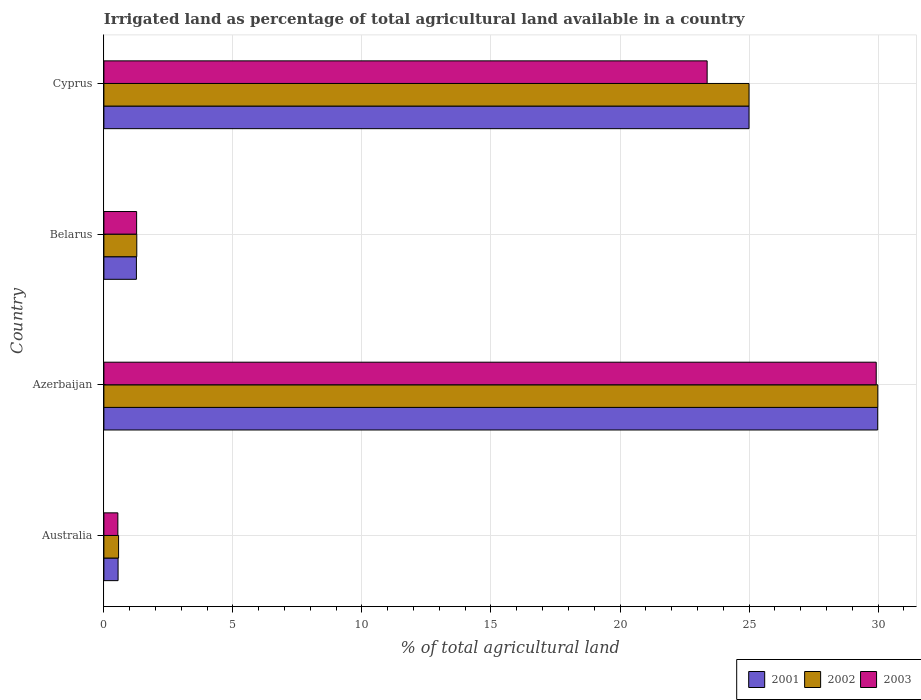How many groups of bars are there?
Ensure brevity in your answer.  4. What is the label of the 2nd group of bars from the top?
Your response must be concise. Belarus. In how many cases, is the number of bars for a given country not equal to the number of legend labels?
Your response must be concise. 0. What is the percentage of irrigated land in 2003 in Australia?
Your answer should be very brief. 0.54. Across all countries, what is the maximum percentage of irrigated land in 2002?
Offer a terse response. 29.99. Across all countries, what is the minimum percentage of irrigated land in 2001?
Ensure brevity in your answer.  0.55. In which country was the percentage of irrigated land in 2002 maximum?
Ensure brevity in your answer.  Azerbaijan. What is the total percentage of irrigated land in 2002 in the graph?
Your answer should be compact. 56.83. What is the difference between the percentage of irrigated land in 2002 in Azerbaijan and that in Belarus?
Your answer should be very brief. 28.72. What is the difference between the percentage of irrigated land in 2003 in Cyprus and the percentage of irrigated land in 2002 in Australia?
Keep it short and to the point. 22.81. What is the average percentage of irrigated land in 2002 per country?
Your answer should be compact. 14.21. What is the difference between the percentage of irrigated land in 2002 and percentage of irrigated land in 2001 in Australia?
Make the answer very short. 0.02. What is the ratio of the percentage of irrigated land in 2002 in Australia to that in Belarus?
Your response must be concise. 0.45. Is the percentage of irrigated land in 2002 in Azerbaijan less than that in Cyprus?
Make the answer very short. No. What is the difference between the highest and the second highest percentage of irrigated land in 2003?
Your answer should be very brief. 6.55. What is the difference between the highest and the lowest percentage of irrigated land in 2003?
Give a very brief answer. 29.39. In how many countries, is the percentage of irrigated land in 2003 greater than the average percentage of irrigated land in 2003 taken over all countries?
Your answer should be very brief. 2. Is it the case that in every country, the sum of the percentage of irrigated land in 2003 and percentage of irrigated land in 2002 is greater than the percentage of irrigated land in 2001?
Give a very brief answer. Yes. What is the difference between two consecutive major ticks on the X-axis?
Offer a terse response. 5. How are the legend labels stacked?
Give a very brief answer. Horizontal. What is the title of the graph?
Provide a short and direct response. Irrigated land as percentage of total agricultural land available in a country. What is the label or title of the X-axis?
Your answer should be very brief. % of total agricultural land. What is the % of total agricultural land in 2001 in Australia?
Provide a succinct answer. 0.55. What is the % of total agricultural land of 2002 in Australia?
Give a very brief answer. 0.57. What is the % of total agricultural land in 2003 in Australia?
Keep it short and to the point. 0.54. What is the % of total agricultural land of 2001 in Azerbaijan?
Provide a short and direct response. 29.99. What is the % of total agricultural land in 2002 in Azerbaijan?
Ensure brevity in your answer.  29.99. What is the % of total agricultural land in 2003 in Azerbaijan?
Ensure brevity in your answer.  29.93. What is the % of total agricultural land in 2001 in Belarus?
Offer a very short reply. 1.26. What is the % of total agricultural land in 2002 in Belarus?
Your answer should be compact. 1.27. What is the % of total agricultural land in 2003 in Belarus?
Your response must be concise. 1.27. What is the % of total agricultural land of 2003 in Cyprus?
Give a very brief answer. 23.38. Across all countries, what is the maximum % of total agricultural land in 2001?
Offer a very short reply. 29.99. Across all countries, what is the maximum % of total agricultural land of 2002?
Provide a succinct answer. 29.99. Across all countries, what is the maximum % of total agricultural land in 2003?
Your response must be concise. 29.93. Across all countries, what is the minimum % of total agricultural land in 2001?
Your answer should be very brief. 0.55. Across all countries, what is the minimum % of total agricultural land in 2002?
Keep it short and to the point. 0.57. Across all countries, what is the minimum % of total agricultural land of 2003?
Make the answer very short. 0.54. What is the total % of total agricultural land of 2001 in the graph?
Make the answer very short. 56.8. What is the total % of total agricultural land in 2002 in the graph?
Give a very brief answer. 56.83. What is the total % of total agricultural land in 2003 in the graph?
Keep it short and to the point. 55.12. What is the difference between the % of total agricultural land in 2001 in Australia and that in Azerbaijan?
Offer a very short reply. -29.44. What is the difference between the % of total agricultural land of 2002 in Australia and that in Azerbaijan?
Your answer should be compact. -29.42. What is the difference between the % of total agricultural land of 2003 in Australia and that in Azerbaijan?
Give a very brief answer. -29.39. What is the difference between the % of total agricultural land of 2001 in Australia and that in Belarus?
Offer a very short reply. -0.71. What is the difference between the % of total agricultural land in 2002 in Australia and that in Belarus?
Give a very brief answer. -0.7. What is the difference between the % of total agricultural land of 2003 in Australia and that in Belarus?
Provide a short and direct response. -0.73. What is the difference between the % of total agricultural land of 2001 in Australia and that in Cyprus?
Offer a terse response. -24.45. What is the difference between the % of total agricultural land of 2002 in Australia and that in Cyprus?
Your response must be concise. -24.43. What is the difference between the % of total agricultural land of 2003 in Australia and that in Cyprus?
Ensure brevity in your answer.  -22.84. What is the difference between the % of total agricultural land of 2001 in Azerbaijan and that in Belarus?
Provide a succinct answer. 28.73. What is the difference between the % of total agricultural land of 2002 in Azerbaijan and that in Belarus?
Give a very brief answer. 28.72. What is the difference between the % of total agricultural land in 2003 in Azerbaijan and that in Belarus?
Provide a short and direct response. 28.66. What is the difference between the % of total agricultural land of 2001 in Azerbaijan and that in Cyprus?
Provide a succinct answer. 4.99. What is the difference between the % of total agricultural land of 2002 in Azerbaijan and that in Cyprus?
Provide a succinct answer. 4.99. What is the difference between the % of total agricultural land of 2003 in Azerbaijan and that in Cyprus?
Make the answer very short. 6.55. What is the difference between the % of total agricultural land of 2001 in Belarus and that in Cyprus?
Make the answer very short. -23.74. What is the difference between the % of total agricultural land in 2002 in Belarus and that in Cyprus?
Your answer should be very brief. -23.73. What is the difference between the % of total agricultural land in 2003 in Belarus and that in Cyprus?
Your response must be concise. -22.11. What is the difference between the % of total agricultural land of 2001 in Australia and the % of total agricultural land of 2002 in Azerbaijan?
Make the answer very short. -29.44. What is the difference between the % of total agricultural land of 2001 in Australia and the % of total agricultural land of 2003 in Azerbaijan?
Your answer should be compact. -29.38. What is the difference between the % of total agricultural land in 2002 in Australia and the % of total agricultural land in 2003 in Azerbaijan?
Keep it short and to the point. -29.36. What is the difference between the % of total agricultural land of 2001 in Australia and the % of total agricultural land of 2002 in Belarus?
Offer a terse response. -0.72. What is the difference between the % of total agricultural land in 2001 in Australia and the % of total agricultural land in 2003 in Belarus?
Your answer should be compact. -0.72. What is the difference between the % of total agricultural land of 2002 in Australia and the % of total agricultural land of 2003 in Belarus?
Provide a succinct answer. -0.7. What is the difference between the % of total agricultural land of 2001 in Australia and the % of total agricultural land of 2002 in Cyprus?
Your response must be concise. -24.45. What is the difference between the % of total agricultural land in 2001 in Australia and the % of total agricultural land in 2003 in Cyprus?
Your answer should be compact. -22.83. What is the difference between the % of total agricultural land in 2002 in Australia and the % of total agricultural land in 2003 in Cyprus?
Your response must be concise. -22.81. What is the difference between the % of total agricultural land in 2001 in Azerbaijan and the % of total agricultural land in 2002 in Belarus?
Provide a succinct answer. 28.71. What is the difference between the % of total agricultural land of 2001 in Azerbaijan and the % of total agricultural land of 2003 in Belarus?
Your answer should be very brief. 28.72. What is the difference between the % of total agricultural land of 2002 in Azerbaijan and the % of total agricultural land of 2003 in Belarus?
Your answer should be very brief. 28.72. What is the difference between the % of total agricultural land in 2001 in Azerbaijan and the % of total agricultural land in 2002 in Cyprus?
Your answer should be compact. 4.99. What is the difference between the % of total agricultural land of 2001 in Azerbaijan and the % of total agricultural land of 2003 in Cyprus?
Provide a short and direct response. 6.61. What is the difference between the % of total agricultural land in 2002 in Azerbaijan and the % of total agricultural land in 2003 in Cyprus?
Ensure brevity in your answer.  6.61. What is the difference between the % of total agricultural land of 2001 in Belarus and the % of total agricultural land of 2002 in Cyprus?
Your answer should be very brief. -23.74. What is the difference between the % of total agricultural land of 2001 in Belarus and the % of total agricultural land of 2003 in Cyprus?
Ensure brevity in your answer.  -22.12. What is the difference between the % of total agricultural land of 2002 in Belarus and the % of total agricultural land of 2003 in Cyprus?
Your response must be concise. -22.1. What is the average % of total agricultural land of 2001 per country?
Your answer should be compact. 14.2. What is the average % of total agricultural land of 2002 per country?
Make the answer very short. 14.21. What is the average % of total agricultural land of 2003 per country?
Your answer should be very brief. 13.78. What is the difference between the % of total agricultural land in 2001 and % of total agricultural land in 2002 in Australia?
Provide a succinct answer. -0.02. What is the difference between the % of total agricultural land in 2001 and % of total agricultural land in 2003 in Australia?
Ensure brevity in your answer.  0.01. What is the difference between the % of total agricultural land of 2002 and % of total agricultural land of 2003 in Australia?
Ensure brevity in your answer.  0.03. What is the difference between the % of total agricultural land of 2001 and % of total agricultural land of 2002 in Azerbaijan?
Give a very brief answer. -0. What is the difference between the % of total agricultural land of 2001 and % of total agricultural land of 2003 in Azerbaijan?
Make the answer very short. 0.06. What is the difference between the % of total agricultural land in 2002 and % of total agricultural land in 2003 in Azerbaijan?
Offer a very short reply. 0.06. What is the difference between the % of total agricultural land in 2001 and % of total agricultural land in 2002 in Belarus?
Provide a short and direct response. -0.01. What is the difference between the % of total agricultural land of 2001 and % of total agricultural land of 2003 in Belarus?
Keep it short and to the point. -0.01. What is the difference between the % of total agricultural land of 2002 and % of total agricultural land of 2003 in Belarus?
Your response must be concise. 0.01. What is the difference between the % of total agricultural land in 2001 and % of total agricultural land in 2003 in Cyprus?
Make the answer very short. 1.62. What is the difference between the % of total agricultural land of 2002 and % of total agricultural land of 2003 in Cyprus?
Provide a succinct answer. 1.62. What is the ratio of the % of total agricultural land in 2001 in Australia to that in Azerbaijan?
Your answer should be compact. 0.02. What is the ratio of the % of total agricultural land in 2002 in Australia to that in Azerbaijan?
Your response must be concise. 0.02. What is the ratio of the % of total agricultural land of 2003 in Australia to that in Azerbaijan?
Provide a succinct answer. 0.02. What is the ratio of the % of total agricultural land in 2001 in Australia to that in Belarus?
Provide a succinct answer. 0.44. What is the ratio of the % of total agricultural land in 2002 in Australia to that in Belarus?
Your answer should be compact. 0.45. What is the ratio of the % of total agricultural land of 2003 in Australia to that in Belarus?
Your answer should be compact. 0.43. What is the ratio of the % of total agricultural land in 2001 in Australia to that in Cyprus?
Ensure brevity in your answer.  0.02. What is the ratio of the % of total agricultural land of 2002 in Australia to that in Cyprus?
Keep it short and to the point. 0.02. What is the ratio of the % of total agricultural land of 2003 in Australia to that in Cyprus?
Provide a succinct answer. 0.02. What is the ratio of the % of total agricultural land of 2001 in Azerbaijan to that in Belarus?
Your answer should be very brief. 23.8. What is the ratio of the % of total agricultural land of 2002 in Azerbaijan to that in Belarus?
Offer a very short reply. 23.54. What is the ratio of the % of total agricultural land in 2003 in Azerbaijan to that in Belarus?
Keep it short and to the point. 23.59. What is the ratio of the % of total agricultural land of 2001 in Azerbaijan to that in Cyprus?
Give a very brief answer. 1.2. What is the ratio of the % of total agricultural land of 2002 in Azerbaijan to that in Cyprus?
Your answer should be compact. 1.2. What is the ratio of the % of total agricultural land in 2003 in Azerbaijan to that in Cyprus?
Your answer should be compact. 1.28. What is the ratio of the % of total agricultural land in 2001 in Belarus to that in Cyprus?
Your answer should be compact. 0.05. What is the ratio of the % of total agricultural land in 2002 in Belarus to that in Cyprus?
Provide a succinct answer. 0.05. What is the ratio of the % of total agricultural land of 2003 in Belarus to that in Cyprus?
Your answer should be very brief. 0.05. What is the difference between the highest and the second highest % of total agricultural land in 2001?
Your answer should be compact. 4.99. What is the difference between the highest and the second highest % of total agricultural land of 2002?
Give a very brief answer. 4.99. What is the difference between the highest and the second highest % of total agricultural land in 2003?
Make the answer very short. 6.55. What is the difference between the highest and the lowest % of total agricultural land in 2001?
Your response must be concise. 29.44. What is the difference between the highest and the lowest % of total agricultural land of 2002?
Offer a very short reply. 29.42. What is the difference between the highest and the lowest % of total agricultural land in 2003?
Your answer should be compact. 29.39. 